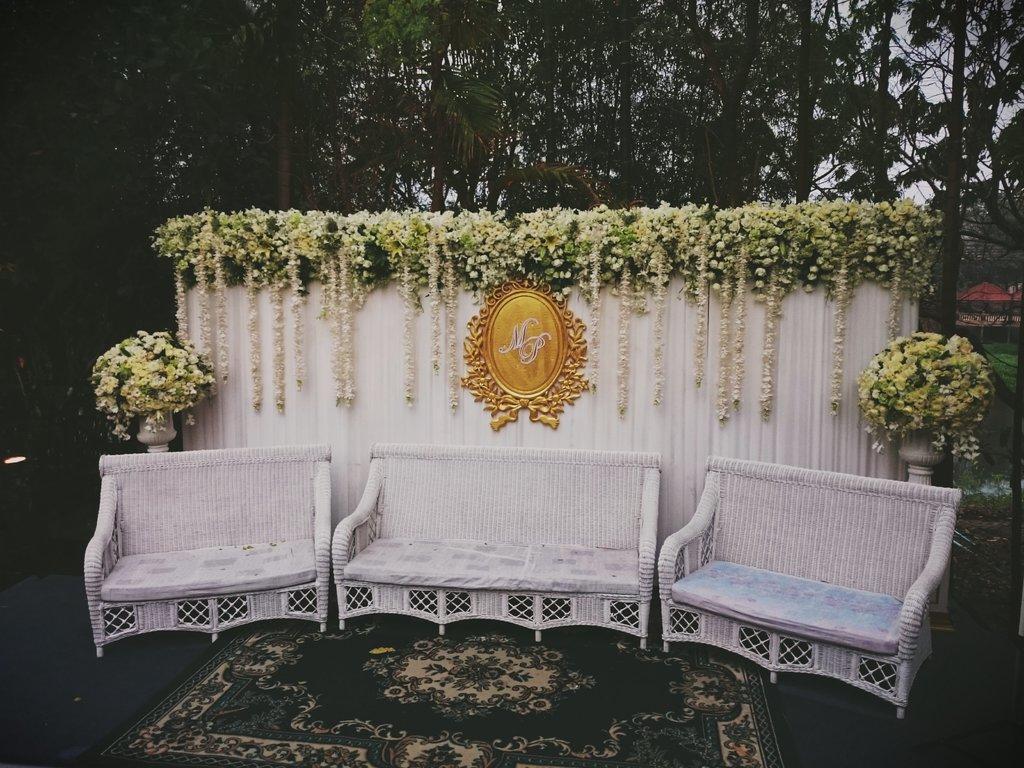Describe this image in one or two sentences. Three sofa sets are arranged with a carpet below them. There are garlands,flower with leaves on a white screen behind them. There are two bouquets on either side. 